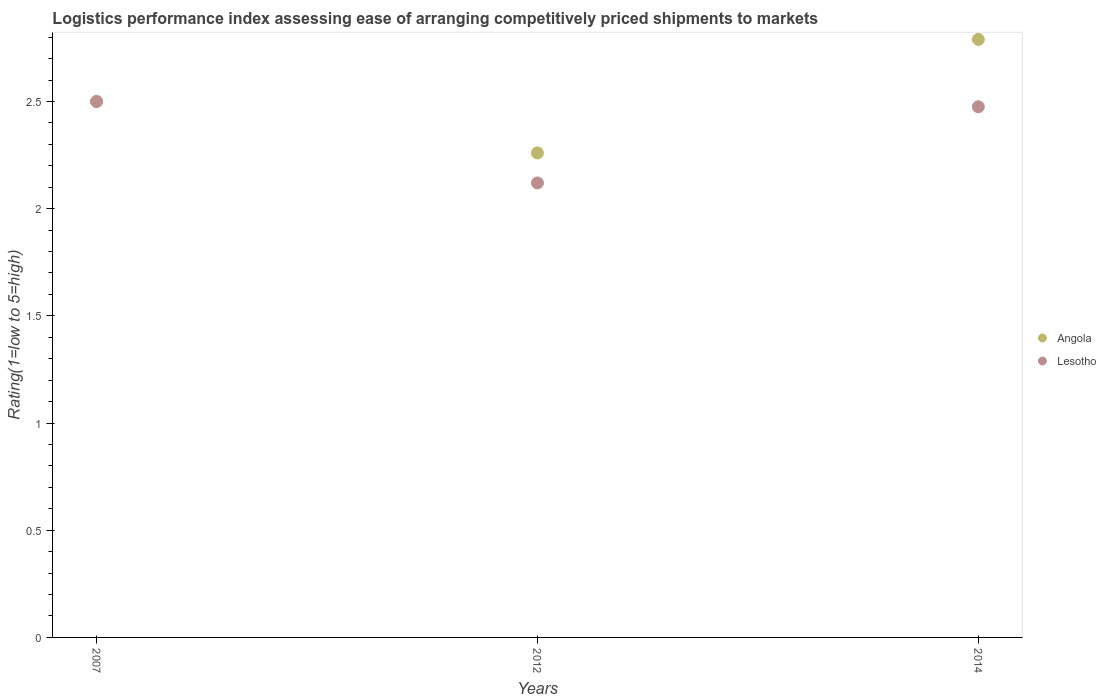How many different coloured dotlines are there?
Your response must be concise. 2. Is the number of dotlines equal to the number of legend labels?
Ensure brevity in your answer.  Yes. What is the Logistic performance index in Angola in 2012?
Your answer should be very brief. 2.26. Across all years, what is the maximum Logistic performance index in Angola?
Your response must be concise. 2.79. Across all years, what is the minimum Logistic performance index in Angola?
Your answer should be compact. 2.26. In which year was the Logistic performance index in Angola maximum?
Your answer should be compact. 2014. What is the total Logistic performance index in Lesotho in the graph?
Offer a very short reply. 7.1. What is the difference between the Logistic performance index in Lesotho in 2012 and that in 2014?
Keep it short and to the point. -0.36. What is the difference between the Logistic performance index in Lesotho in 2007 and the Logistic performance index in Angola in 2012?
Offer a very short reply. 0.24. What is the average Logistic performance index in Angola per year?
Ensure brevity in your answer.  2.52. In the year 2014, what is the difference between the Logistic performance index in Lesotho and Logistic performance index in Angola?
Offer a very short reply. -0.31. In how many years, is the Logistic performance index in Angola greater than 0.30000000000000004?
Keep it short and to the point. 3. What is the ratio of the Logistic performance index in Angola in 2012 to that in 2014?
Keep it short and to the point. 0.81. Is the Logistic performance index in Lesotho in 2012 less than that in 2014?
Offer a terse response. Yes. Is the difference between the Logistic performance index in Lesotho in 2007 and 2014 greater than the difference between the Logistic performance index in Angola in 2007 and 2014?
Your answer should be very brief. Yes. What is the difference between the highest and the second highest Logistic performance index in Lesotho?
Your response must be concise. 0.02. What is the difference between the highest and the lowest Logistic performance index in Angola?
Your answer should be compact. 0.53. Is the Logistic performance index in Lesotho strictly less than the Logistic performance index in Angola over the years?
Offer a very short reply. No. How many years are there in the graph?
Your answer should be very brief. 3. What is the difference between two consecutive major ticks on the Y-axis?
Give a very brief answer. 0.5. Does the graph contain any zero values?
Your answer should be compact. No. How are the legend labels stacked?
Make the answer very short. Vertical. What is the title of the graph?
Provide a short and direct response. Logistics performance index assessing ease of arranging competitively priced shipments to markets. What is the label or title of the Y-axis?
Provide a succinct answer. Rating(1=low to 5=high). What is the Rating(1=low to 5=high) of Angola in 2007?
Provide a short and direct response. 2.5. What is the Rating(1=low to 5=high) of Angola in 2012?
Offer a very short reply. 2.26. What is the Rating(1=low to 5=high) of Lesotho in 2012?
Provide a short and direct response. 2.12. What is the Rating(1=low to 5=high) in Angola in 2014?
Your answer should be compact. 2.79. What is the Rating(1=low to 5=high) in Lesotho in 2014?
Make the answer very short. 2.48. Across all years, what is the maximum Rating(1=low to 5=high) in Angola?
Keep it short and to the point. 2.79. Across all years, what is the minimum Rating(1=low to 5=high) of Angola?
Your answer should be very brief. 2.26. Across all years, what is the minimum Rating(1=low to 5=high) in Lesotho?
Offer a terse response. 2.12. What is the total Rating(1=low to 5=high) in Angola in the graph?
Keep it short and to the point. 7.55. What is the total Rating(1=low to 5=high) in Lesotho in the graph?
Provide a succinct answer. 7.1. What is the difference between the Rating(1=low to 5=high) of Angola in 2007 and that in 2012?
Ensure brevity in your answer.  0.24. What is the difference between the Rating(1=low to 5=high) of Lesotho in 2007 and that in 2012?
Offer a terse response. 0.38. What is the difference between the Rating(1=low to 5=high) in Angola in 2007 and that in 2014?
Offer a very short reply. -0.29. What is the difference between the Rating(1=low to 5=high) of Lesotho in 2007 and that in 2014?
Offer a very short reply. 0.02. What is the difference between the Rating(1=low to 5=high) of Angola in 2012 and that in 2014?
Your answer should be very brief. -0.53. What is the difference between the Rating(1=low to 5=high) in Lesotho in 2012 and that in 2014?
Your answer should be compact. -0.36. What is the difference between the Rating(1=low to 5=high) in Angola in 2007 and the Rating(1=low to 5=high) in Lesotho in 2012?
Provide a succinct answer. 0.38. What is the difference between the Rating(1=low to 5=high) in Angola in 2007 and the Rating(1=low to 5=high) in Lesotho in 2014?
Keep it short and to the point. 0.02. What is the difference between the Rating(1=low to 5=high) in Angola in 2012 and the Rating(1=low to 5=high) in Lesotho in 2014?
Keep it short and to the point. -0.22. What is the average Rating(1=low to 5=high) in Angola per year?
Make the answer very short. 2.52. What is the average Rating(1=low to 5=high) of Lesotho per year?
Your answer should be very brief. 2.37. In the year 2012, what is the difference between the Rating(1=low to 5=high) of Angola and Rating(1=low to 5=high) of Lesotho?
Your answer should be very brief. 0.14. In the year 2014, what is the difference between the Rating(1=low to 5=high) of Angola and Rating(1=low to 5=high) of Lesotho?
Your answer should be compact. 0.31. What is the ratio of the Rating(1=low to 5=high) in Angola in 2007 to that in 2012?
Provide a short and direct response. 1.11. What is the ratio of the Rating(1=low to 5=high) of Lesotho in 2007 to that in 2012?
Provide a succinct answer. 1.18. What is the ratio of the Rating(1=low to 5=high) in Angola in 2007 to that in 2014?
Offer a terse response. 0.9. What is the ratio of the Rating(1=low to 5=high) in Lesotho in 2007 to that in 2014?
Your response must be concise. 1.01. What is the ratio of the Rating(1=low to 5=high) of Angola in 2012 to that in 2014?
Your response must be concise. 0.81. What is the ratio of the Rating(1=low to 5=high) of Lesotho in 2012 to that in 2014?
Give a very brief answer. 0.86. What is the difference between the highest and the second highest Rating(1=low to 5=high) of Angola?
Your response must be concise. 0.29. What is the difference between the highest and the second highest Rating(1=low to 5=high) of Lesotho?
Your answer should be very brief. 0.02. What is the difference between the highest and the lowest Rating(1=low to 5=high) of Angola?
Your answer should be very brief. 0.53. What is the difference between the highest and the lowest Rating(1=low to 5=high) of Lesotho?
Your response must be concise. 0.38. 